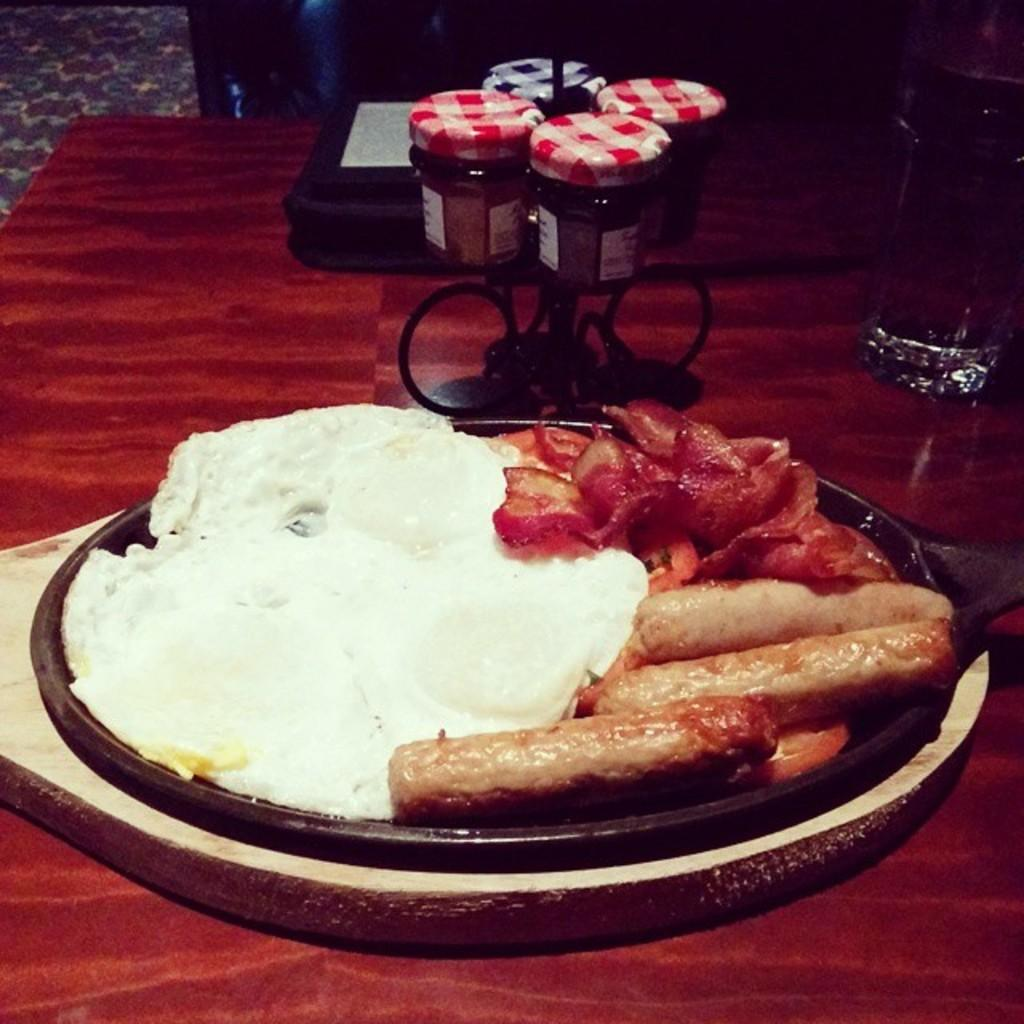What type of furniture is present in the image? There is a table in the image. What can be found on the table in the image? There are food items on the table. What type of competition is taking place at the table in the image? There is no competition present in the image; it simply shows a table with food items on it. Is there any poison visible on the table in the image? There is no mention of poison in the image; it only shows food items on a table. 